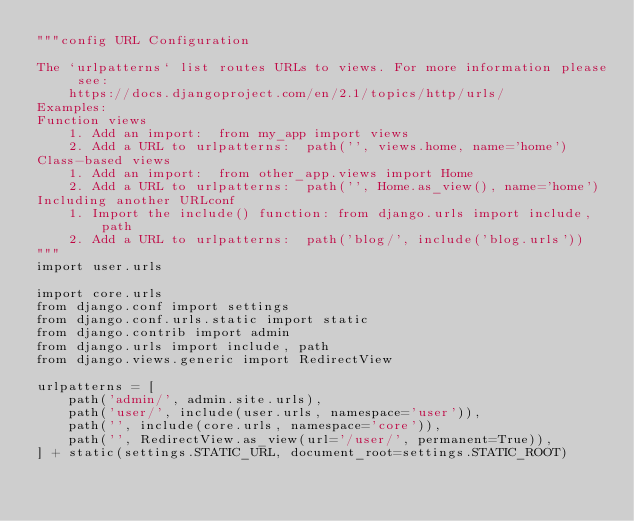Convert code to text. <code><loc_0><loc_0><loc_500><loc_500><_Python_>"""config URL Configuration

The `urlpatterns` list routes URLs to views. For more information please see:
    https://docs.djangoproject.com/en/2.1/topics/http/urls/
Examples:
Function views
    1. Add an import:  from my_app import views
    2. Add a URL to urlpatterns:  path('', views.home, name='home')
Class-based views
    1. Add an import:  from other_app.views import Home
    2. Add a URL to urlpatterns:  path('', Home.as_view(), name='home')
Including another URLconf
    1. Import the include() function: from django.urls import include, path
    2. Add a URL to urlpatterns:  path('blog/', include('blog.urls'))
"""
import user.urls

import core.urls
from django.conf import settings
from django.conf.urls.static import static
from django.contrib import admin
from django.urls import include, path
from django.views.generic import RedirectView

urlpatterns = [
    path('admin/', admin.site.urls),
    path('user/', include(user.urls, namespace='user')),
    path('', include(core.urls, namespace='core')),
    path('', RedirectView.as_view(url='/user/', permanent=True)),
] + static(settings.STATIC_URL, document_root=settings.STATIC_ROOT)
</code> 